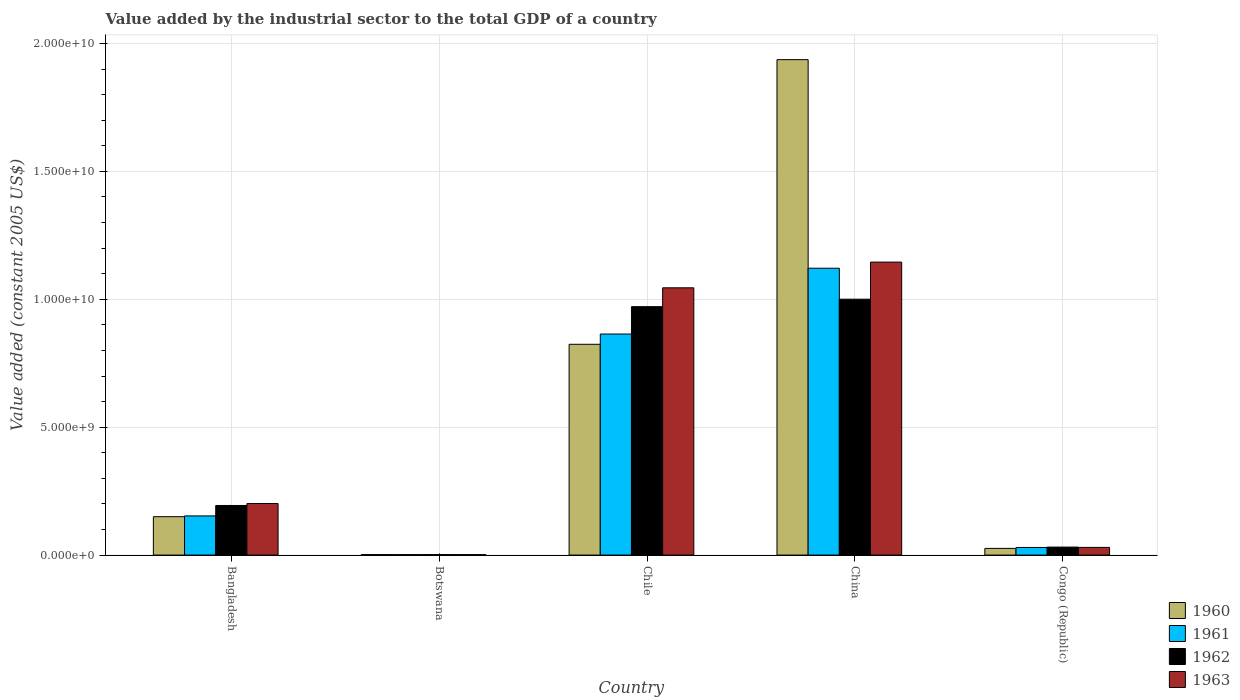How many different coloured bars are there?
Your response must be concise. 4. How many groups of bars are there?
Keep it short and to the point. 5. Are the number of bars per tick equal to the number of legend labels?
Give a very brief answer. Yes. Are the number of bars on each tick of the X-axis equal?
Offer a terse response. Yes. How many bars are there on the 1st tick from the left?
Make the answer very short. 4. How many bars are there on the 3rd tick from the right?
Your answer should be very brief. 4. What is the value added by the industrial sector in 1961 in Chile?
Offer a terse response. 8.64e+09. Across all countries, what is the maximum value added by the industrial sector in 1962?
Your answer should be compact. 1.00e+1. Across all countries, what is the minimum value added by the industrial sector in 1960?
Keep it short and to the point. 1.96e+07. In which country was the value added by the industrial sector in 1961 maximum?
Make the answer very short. China. In which country was the value added by the industrial sector in 1960 minimum?
Provide a short and direct response. Botswana. What is the total value added by the industrial sector in 1960 in the graph?
Your response must be concise. 2.94e+1. What is the difference between the value added by the industrial sector in 1960 in Bangladesh and that in Congo (Republic)?
Your answer should be very brief. 1.24e+09. What is the difference between the value added by the industrial sector in 1962 in Botswana and the value added by the industrial sector in 1961 in China?
Ensure brevity in your answer.  -1.12e+1. What is the average value added by the industrial sector in 1963 per country?
Give a very brief answer. 4.85e+09. What is the difference between the value added by the industrial sector of/in 1963 and value added by the industrial sector of/in 1962 in China?
Offer a very short reply. 1.45e+09. In how many countries, is the value added by the industrial sector in 1962 greater than 6000000000 US$?
Make the answer very short. 2. What is the ratio of the value added by the industrial sector in 1963 in Chile to that in China?
Provide a short and direct response. 0.91. Is the difference between the value added by the industrial sector in 1963 in Bangladesh and China greater than the difference between the value added by the industrial sector in 1962 in Bangladesh and China?
Your answer should be compact. No. What is the difference between the highest and the second highest value added by the industrial sector in 1960?
Ensure brevity in your answer.  1.79e+1. What is the difference between the highest and the lowest value added by the industrial sector in 1962?
Provide a succinct answer. 9.98e+09. In how many countries, is the value added by the industrial sector in 1963 greater than the average value added by the industrial sector in 1963 taken over all countries?
Provide a succinct answer. 2. Is the sum of the value added by the industrial sector in 1961 in Bangladesh and China greater than the maximum value added by the industrial sector in 1962 across all countries?
Offer a terse response. Yes. Is it the case that in every country, the sum of the value added by the industrial sector in 1960 and value added by the industrial sector in 1962 is greater than the sum of value added by the industrial sector in 1961 and value added by the industrial sector in 1963?
Keep it short and to the point. No. What does the 4th bar from the left in Chile represents?
Provide a succinct answer. 1963. Are all the bars in the graph horizontal?
Your response must be concise. No. How many countries are there in the graph?
Offer a terse response. 5. What is the difference between two consecutive major ticks on the Y-axis?
Your answer should be compact. 5.00e+09. Are the values on the major ticks of Y-axis written in scientific E-notation?
Offer a very short reply. Yes. Where does the legend appear in the graph?
Give a very brief answer. Bottom right. How are the legend labels stacked?
Give a very brief answer. Vertical. What is the title of the graph?
Your answer should be compact. Value added by the industrial sector to the total GDP of a country. Does "1994" appear as one of the legend labels in the graph?
Your answer should be compact. No. What is the label or title of the Y-axis?
Your response must be concise. Value added (constant 2005 US$). What is the Value added (constant 2005 US$) in 1960 in Bangladesh?
Give a very brief answer. 1.50e+09. What is the Value added (constant 2005 US$) of 1961 in Bangladesh?
Provide a short and direct response. 1.53e+09. What is the Value added (constant 2005 US$) of 1962 in Bangladesh?
Ensure brevity in your answer.  1.94e+09. What is the Value added (constant 2005 US$) in 1963 in Bangladesh?
Your answer should be compact. 2.01e+09. What is the Value added (constant 2005 US$) in 1960 in Botswana?
Your answer should be very brief. 1.96e+07. What is the Value added (constant 2005 US$) in 1961 in Botswana?
Your answer should be compact. 1.92e+07. What is the Value added (constant 2005 US$) in 1962 in Botswana?
Your answer should be compact. 1.98e+07. What is the Value added (constant 2005 US$) in 1963 in Botswana?
Your answer should be compact. 1.83e+07. What is the Value added (constant 2005 US$) of 1960 in Chile?
Make the answer very short. 8.24e+09. What is the Value added (constant 2005 US$) of 1961 in Chile?
Offer a very short reply. 8.64e+09. What is the Value added (constant 2005 US$) in 1962 in Chile?
Keep it short and to the point. 9.71e+09. What is the Value added (constant 2005 US$) of 1963 in Chile?
Provide a short and direct response. 1.04e+1. What is the Value added (constant 2005 US$) of 1960 in China?
Offer a very short reply. 1.94e+1. What is the Value added (constant 2005 US$) in 1961 in China?
Provide a short and direct response. 1.12e+1. What is the Value added (constant 2005 US$) in 1962 in China?
Give a very brief answer. 1.00e+1. What is the Value added (constant 2005 US$) in 1963 in China?
Your answer should be very brief. 1.15e+1. What is the Value added (constant 2005 US$) in 1960 in Congo (Republic)?
Offer a very short reply. 2.61e+08. What is the Value added (constant 2005 US$) in 1961 in Congo (Republic)?
Offer a very short reply. 2.98e+08. What is the Value added (constant 2005 US$) of 1962 in Congo (Republic)?
Provide a succinct answer. 3.12e+08. What is the Value added (constant 2005 US$) in 1963 in Congo (Republic)?
Keep it short and to the point. 3.00e+08. Across all countries, what is the maximum Value added (constant 2005 US$) in 1960?
Make the answer very short. 1.94e+1. Across all countries, what is the maximum Value added (constant 2005 US$) of 1961?
Provide a short and direct response. 1.12e+1. Across all countries, what is the maximum Value added (constant 2005 US$) of 1962?
Offer a very short reply. 1.00e+1. Across all countries, what is the maximum Value added (constant 2005 US$) of 1963?
Offer a very short reply. 1.15e+1. Across all countries, what is the minimum Value added (constant 2005 US$) of 1960?
Ensure brevity in your answer.  1.96e+07. Across all countries, what is the minimum Value added (constant 2005 US$) of 1961?
Keep it short and to the point. 1.92e+07. Across all countries, what is the minimum Value added (constant 2005 US$) in 1962?
Provide a short and direct response. 1.98e+07. Across all countries, what is the minimum Value added (constant 2005 US$) of 1963?
Make the answer very short. 1.83e+07. What is the total Value added (constant 2005 US$) of 1960 in the graph?
Make the answer very short. 2.94e+1. What is the total Value added (constant 2005 US$) of 1961 in the graph?
Offer a very short reply. 2.17e+1. What is the total Value added (constant 2005 US$) of 1962 in the graph?
Keep it short and to the point. 2.20e+1. What is the total Value added (constant 2005 US$) of 1963 in the graph?
Make the answer very short. 2.42e+1. What is the difference between the Value added (constant 2005 US$) of 1960 in Bangladesh and that in Botswana?
Ensure brevity in your answer.  1.48e+09. What is the difference between the Value added (constant 2005 US$) in 1961 in Bangladesh and that in Botswana?
Your answer should be very brief. 1.51e+09. What is the difference between the Value added (constant 2005 US$) in 1962 in Bangladesh and that in Botswana?
Give a very brief answer. 1.92e+09. What is the difference between the Value added (constant 2005 US$) in 1963 in Bangladesh and that in Botswana?
Give a very brief answer. 2.00e+09. What is the difference between the Value added (constant 2005 US$) of 1960 in Bangladesh and that in Chile?
Your answer should be very brief. -6.74e+09. What is the difference between the Value added (constant 2005 US$) of 1961 in Bangladesh and that in Chile?
Your response must be concise. -7.11e+09. What is the difference between the Value added (constant 2005 US$) of 1962 in Bangladesh and that in Chile?
Provide a succinct answer. -7.77e+09. What is the difference between the Value added (constant 2005 US$) of 1963 in Bangladesh and that in Chile?
Your answer should be very brief. -8.43e+09. What is the difference between the Value added (constant 2005 US$) in 1960 in Bangladesh and that in China?
Your answer should be compact. -1.79e+1. What is the difference between the Value added (constant 2005 US$) in 1961 in Bangladesh and that in China?
Your response must be concise. -9.68e+09. What is the difference between the Value added (constant 2005 US$) in 1962 in Bangladesh and that in China?
Your response must be concise. -8.06e+09. What is the difference between the Value added (constant 2005 US$) of 1963 in Bangladesh and that in China?
Your answer should be very brief. -9.44e+09. What is the difference between the Value added (constant 2005 US$) in 1960 in Bangladesh and that in Congo (Republic)?
Ensure brevity in your answer.  1.24e+09. What is the difference between the Value added (constant 2005 US$) in 1961 in Bangladesh and that in Congo (Republic)?
Give a very brief answer. 1.23e+09. What is the difference between the Value added (constant 2005 US$) of 1962 in Bangladesh and that in Congo (Republic)?
Ensure brevity in your answer.  1.63e+09. What is the difference between the Value added (constant 2005 US$) of 1963 in Bangladesh and that in Congo (Republic)?
Give a very brief answer. 1.71e+09. What is the difference between the Value added (constant 2005 US$) in 1960 in Botswana and that in Chile?
Make the answer very short. -8.22e+09. What is the difference between the Value added (constant 2005 US$) of 1961 in Botswana and that in Chile?
Make the answer very short. -8.62e+09. What is the difference between the Value added (constant 2005 US$) of 1962 in Botswana and that in Chile?
Provide a succinct answer. -9.69e+09. What is the difference between the Value added (constant 2005 US$) in 1963 in Botswana and that in Chile?
Make the answer very short. -1.04e+1. What is the difference between the Value added (constant 2005 US$) of 1960 in Botswana and that in China?
Give a very brief answer. -1.93e+1. What is the difference between the Value added (constant 2005 US$) of 1961 in Botswana and that in China?
Provide a succinct answer. -1.12e+1. What is the difference between the Value added (constant 2005 US$) of 1962 in Botswana and that in China?
Ensure brevity in your answer.  -9.98e+09. What is the difference between the Value added (constant 2005 US$) in 1963 in Botswana and that in China?
Give a very brief answer. -1.14e+1. What is the difference between the Value added (constant 2005 US$) of 1960 in Botswana and that in Congo (Republic)?
Offer a very short reply. -2.42e+08. What is the difference between the Value added (constant 2005 US$) of 1961 in Botswana and that in Congo (Republic)?
Ensure brevity in your answer.  -2.78e+08. What is the difference between the Value added (constant 2005 US$) of 1962 in Botswana and that in Congo (Republic)?
Provide a succinct answer. -2.93e+08. What is the difference between the Value added (constant 2005 US$) in 1963 in Botswana and that in Congo (Republic)?
Keep it short and to the point. -2.81e+08. What is the difference between the Value added (constant 2005 US$) in 1960 in Chile and that in China?
Give a very brief answer. -1.11e+1. What is the difference between the Value added (constant 2005 US$) in 1961 in Chile and that in China?
Offer a very short reply. -2.57e+09. What is the difference between the Value added (constant 2005 US$) in 1962 in Chile and that in China?
Your response must be concise. -2.92e+08. What is the difference between the Value added (constant 2005 US$) in 1963 in Chile and that in China?
Ensure brevity in your answer.  -1.01e+09. What is the difference between the Value added (constant 2005 US$) of 1960 in Chile and that in Congo (Republic)?
Your answer should be compact. 7.98e+09. What is the difference between the Value added (constant 2005 US$) in 1961 in Chile and that in Congo (Republic)?
Your response must be concise. 8.34e+09. What is the difference between the Value added (constant 2005 US$) in 1962 in Chile and that in Congo (Republic)?
Provide a short and direct response. 9.40e+09. What is the difference between the Value added (constant 2005 US$) of 1963 in Chile and that in Congo (Republic)?
Offer a very short reply. 1.01e+1. What is the difference between the Value added (constant 2005 US$) of 1960 in China and that in Congo (Republic)?
Offer a terse response. 1.91e+1. What is the difference between the Value added (constant 2005 US$) of 1961 in China and that in Congo (Republic)?
Your answer should be compact. 1.09e+1. What is the difference between the Value added (constant 2005 US$) of 1962 in China and that in Congo (Republic)?
Your answer should be compact. 9.69e+09. What is the difference between the Value added (constant 2005 US$) of 1963 in China and that in Congo (Republic)?
Your response must be concise. 1.12e+1. What is the difference between the Value added (constant 2005 US$) in 1960 in Bangladesh and the Value added (constant 2005 US$) in 1961 in Botswana?
Provide a short and direct response. 1.48e+09. What is the difference between the Value added (constant 2005 US$) in 1960 in Bangladesh and the Value added (constant 2005 US$) in 1962 in Botswana?
Make the answer very short. 1.48e+09. What is the difference between the Value added (constant 2005 US$) of 1960 in Bangladesh and the Value added (constant 2005 US$) of 1963 in Botswana?
Your answer should be compact. 1.48e+09. What is the difference between the Value added (constant 2005 US$) in 1961 in Bangladesh and the Value added (constant 2005 US$) in 1962 in Botswana?
Give a very brief answer. 1.51e+09. What is the difference between the Value added (constant 2005 US$) of 1961 in Bangladesh and the Value added (constant 2005 US$) of 1963 in Botswana?
Ensure brevity in your answer.  1.51e+09. What is the difference between the Value added (constant 2005 US$) in 1962 in Bangladesh and the Value added (constant 2005 US$) in 1963 in Botswana?
Your response must be concise. 1.92e+09. What is the difference between the Value added (constant 2005 US$) of 1960 in Bangladesh and the Value added (constant 2005 US$) of 1961 in Chile?
Offer a terse response. -7.14e+09. What is the difference between the Value added (constant 2005 US$) of 1960 in Bangladesh and the Value added (constant 2005 US$) of 1962 in Chile?
Provide a short and direct response. -8.21e+09. What is the difference between the Value added (constant 2005 US$) in 1960 in Bangladesh and the Value added (constant 2005 US$) in 1963 in Chile?
Provide a succinct answer. -8.95e+09. What is the difference between the Value added (constant 2005 US$) in 1961 in Bangladesh and the Value added (constant 2005 US$) in 1962 in Chile?
Offer a very short reply. -8.18e+09. What is the difference between the Value added (constant 2005 US$) in 1961 in Bangladesh and the Value added (constant 2005 US$) in 1963 in Chile?
Make the answer very short. -8.92e+09. What is the difference between the Value added (constant 2005 US$) of 1962 in Bangladesh and the Value added (constant 2005 US$) of 1963 in Chile?
Offer a terse response. -8.51e+09. What is the difference between the Value added (constant 2005 US$) of 1960 in Bangladesh and the Value added (constant 2005 US$) of 1961 in China?
Provide a short and direct response. -9.71e+09. What is the difference between the Value added (constant 2005 US$) of 1960 in Bangladesh and the Value added (constant 2005 US$) of 1962 in China?
Make the answer very short. -8.50e+09. What is the difference between the Value added (constant 2005 US$) in 1960 in Bangladesh and the Value added (constant 2005 US$) in 1963 in China?
Your answer should be very brief. -9.95e+09. What is the difference between the Value added (constant 2005 US$) in 1961 in Bangladesh and the Value added (constant 2005 US$) in 1962 in China?
Provide a succinct answer. -8.47e+09. What is the difference between the Value added (constant 2005 US$) in 1961 in Bangladesh and the Value added (constant 2005 US$) in 1963 in China?
Your answer should be very brief. -9.92e+09. What is the difference between the Value added (constant 2005 US$) in 1962 in Bangladesh and the Value added (constant 2005 US$) in 1963 in China?
Make the answer very short. -9.51e+09. What is the difference between the Value added (constant 2005 US$) of 1960 in Bangladesh and the Value added (constant 2005 US$) of 1961 in Congo (Republic)?
Ensure brevity in your answer.  1.20e+09. What is the difference between the Value added (constant 2005 US$) of 1960 in Bangladesh and the Value added (constant 2005 US$) of 1962 in Congo (Republic)?
Give a very brief answer. 1.19e+09. What is the difference between the Value added (constant 2005 US$) in 1960 in Bangladesh and the Value added (constant 2005 US$) in 1963 in Congo (Republic)?
Offer a terse response. 1.20e+09. What is the difference between the Value added (constant 2005 US$) of 1961 in Bangladesh and the Value added (constant 2005 US$) of 1962 in Congo (Republic)?
Offer a terse response. 1.22e+09. What is the difference between the Value added (constant 2005 US$) in 1961 in Bangladesh and the Value added (constant 2005 US$) in 1963 in Congo (Republic)?
Give a very brief answer. 1.23e+09. What is the difference between the Value added (constant 2005 US$) of 1962 in Bangladesh and the Value added (constant 2005 US$) of 1963 in Congo (Republic)?
Give a very brief answer. 1.64e+09. What is the difference between the Value added (constant 2005 US$) of 1960 in Botswana and the Value added (constant 2005 US$) of 1961 in Chile?
Provide a short and direct response. -8.62e+09. What is the difference between the Value added (constant 2005 US$) in 1960 in Botswana and the Value added (constant 2005 US$) in 1962 in Chile?
Provide a short and direct response. -9.69e+09. What is the difference between the Value added (constant 2005 US$) of 1960 in Botswana and the Value added (constant 2005 US$) of 1963 in Chile?
Offer a terse response. -1.04e+1. What is the difference between the Value added (constant 2005 US$) of 1961 in Botswana and the Value added (constant 2005 US$) of 1962 in Chile?
Give a very brief answer. -9.69e+09. What is the difference between the Value added (constant 2005 US$) of 1961 in Botswana and the Value added (constant 2005 US$) of 1963 in Chile?
Offer a terse response. -1.04e+1. What is the difference between the Value added (constant 2005 US$) in 1962 in Botswana and the Value added (constant 2005 US$) in 1963 in Chile?
Give a very brief answer. -1.04e+1. What is the difference between the Value added (constant 2005 US$) of 1960 in Botswana and the Value added (constant 2005 US$) of 1961 in China?
Offer a terse response. -1.12e+1. What is the difference between the Value added (constant 2005 US$) of 1960 in Botswana and the Value added (constant 2005 US$) of 1962 in China?
Your response must be concise. -9.98e+09. What is the difference between the Value added (constant 2005 US$) of 1960 in Botswana and the Value added (constant 2005 US$) of 1963 in China?
Your answer should be compact. -1.14e+1. What is the difference between the Value added (constant 2005 US$) in 1961 in Botswana and the Value added (constant 2005 US$) in 1962 in China?
Offer a very short reply. -9.98e+09. What is the difference between the Value added (constant 2005 US$) in 1961 in Botswana and the Value added (constant 2005 US$) in 1963 in China?
Your response must be concise. -1.14e+1. What is the difference between the Value added (constant 2005 US$) in 1962 in Botswana and the Value added (constant 2005 US$) in 1963 in China?
Offer a very short reply. -1.14e+1. What is the difference between the Value added (constant 2005 US$) of 1960 in Botswana and the Value added (constant 2005 US$) of 1961 in Congo (Republic)?
Give a very brief answer. -2.78e+08. What is the difference between the Value added (constant 2005 US$) of 1960 in Botswana and the Value added (constant 2005 US$) of 1962 in Congo (Republic)?
Your answer should be compact. -2.93e+08. What is the difference between the Value added (constant 2005 US$) in 1960 in Botswana and the Value added (constant 2005 US$) in 1963 in Congo (Republic)?
Ensure brevity in your answer.  -2.80e+08. What is the difference between the Value added (constant 2005 US$) of 1961 in Botswana and the Value added (constant 2005 US$) of 1962 in Congo (Republic)?
Provide a short and direct response. -2.93e+08. What is the difference between the Value added (constant 2005 US$) of 1961 in Botswana and the Value added (constant 2005 US$) of 1963 in Congo (Republic)?
Your response must be concise. -2.81e+08. What is the difference between the Value added (constant 2005 US$) in 1962 in Botswana and the Value added (constant 2005 US$) in 1963 in Congo (Republic)?
Offer a very short reply. -2.80e+08. What is the difference between the Value added (constant 2005 US$) of 1960 in Chile and the Value added (constant 2005 US$) of 1961 in China?
Your response must be concise. -2.97e+09. What is the difference between the Value added (constant 2005 US$) of 1960 in Chile and the Value added (constant 2005 US$) of 1962 in China?
Your answer should be compact. -1.76e+09. What is the difference between the Value added (constant 2005 US$) in 1960 in Chile and the Value added (constant 2005 US$) in 1963 in China?
Your answer should be compact. -3.21e+09. What is the difference between the Value added (constant 2005 US$) in 1961 in Chile and the Value added (constant 2005 US$) in 1962 in China?
Make the answer very short. -1.36e+09. What is the difference between the Value added (constant 2005 US$) of 1961 in Chile and the Value added (constant 2005 US$) of 1963 in China?
Provide a succinct answer. -2.81e+09. What is the difference between the Value added (constant 2005 US$) of 1962 in Chile and the Value added (constant 2005 US$) of 1963 in China?
Your answer should be compact. -1.74e+09. What is the difference between the Value added (constant 2005 US$) of 1960 in Chile and the Value added (constant 2005 US$) of 1961 in Congo (Republic)?
Your response must be concise. 7.94e+09. What is the difference between the Value added (constant 2005 US$) of 1960 in Chile and the Value added (constant 2005 US$) of 1962 in Congo (Republic)?
Offer a very short reply. 7.93e+09. What is the difference between the Value added (constant 2005 US$) of 1960 in Chile and the Value added (constant 2005 US$) of 1963 in Congo (Republic)?
Your answer should be very brief. 7.94e+09. What is the difference between the Value added (constant 2005 US$) of 1961 in Chile and the Value added (constant 2005 US$) of 1962 in Congo (Republic)?
Offer a terse response. 8.33e+09. What is the difference between the Value added (constant 2005 US$) of 1961 in Chile and the Value added (constant 2005 US$) of 1963 in Congo (Republic)?
Your answer should be very brief. 8.34e+09. What is the difference between the Value added (constant 2005 US$) in 1962 in Chile and the Value added (constant 2005 US$) in 1963 in Congo (Republic)?
Ensure brevity in your answer.  9.41e+09. What is the difference between the Value added (constant 2005 US$) in 1960 in China and the Value added (constant 2005 US$) in 1961 in Congo (Republic)?
Your response must be concise. 1.91e+1. What is the difference between the Value added (constant 2005 US$) in 1960 in China and the Value added (constant 2005 US$) in 1962 in Congo (Republic)?
Provide a succinct answer. 1.91e+1. What is the difference between the Value added (constant 2005 US$) in 1960 in China and the Value added (constant 2005 US$) in 1963 in Congo (Republic)?
Provide a short and direct response. 1.91e+1. What is the difference between the Value added (constant 2005 US$) in 1961 in China and the Value added (constant 2005 US$) in 1962 in Congo (Republic)?
Your response must be concise. 1.09e+1. What is the difference between the Value added (constant 2005 US$) of 1961 in China and the Value added (constant 2005 US$) of 1963 in Congo (Republic)?
Give a very brief answer. 1.09e+1. What is the difference between the Value added (constant 2005 US$) in 1962 in China and the Value added (constant 2005 US$) in 1963 in Congo (Republic)?
Offer a terse response. 9.70e+09. What is the average Value added (constant 2005 US$) in 1960 per country?
Your answer should be very brief. 5.88e+09. What is the average Value added (constant 2005 US$) of 1961 per country?
Offer a very short reply. 4.34e+09. What is the average Value added (constant 2005 US$) of 1962 per country?
Offer a terse response. 4.40e+09. What is the average Value added (constant 2005 US$) in 1963 per country?
Your answer should be very brief. 4.85e+09. What is the difference between the Value added (constant 2005 US$) in 1960 and Value added (constant 2005 US$) in 1961 in Bangladesh?
Your response must be concise. -3.05e+07. What is the difference between the Value added (constant 2005 US$) of 1960 and Value added (constant 2005 US$) of 1962 in Bangladesh?
Ensure brevity in your answer.  -4.38e+08. What is the difference between the Value added (constant 2005 US$) in 1960 and Value added (constant 2005 US$) in 1963 in Bangladesh?
Make the answer very short. -5.14e+08. What is the difference between the Value added (constant 2005 US$) of 1961 and Value added (constant 2005 US$) of 1962 in Bangladesh?
Offer a terse response. -4.08e+08. What is the difference between the Value added (constant 2005 US$) of 1961 and Value added (constant 2005 US$) of 1963 in Bangladesh?
Provide a succinct answer. -4.84e+08. What is the difference between the Value added (constant 2005 US$) in 1962 and Value added (constant 2005 US$) in 1963 in Bangladesh?
Provide a succinct answer. -7.60e+07. What is the difference between the Value added (constant 2005 US$) of 1960 and Value added (constant 2005 US$) of 1961 in Botswana?
Offer a very short reply. 4.24e+05. What is the difference between the Value added (constant 2005 US$) in 1960 and Value added (constant 2005 US$) in 1962 in Botswana?
Keep it short and to the point. -2.12e+05. What is the difference between the Value added (constant 2005 US$) in 1960 and Value added (constant 2005 US$) in 1963 in Botswana?
Your answer should be compact. 1.27e+06. What is the difference between the Value added (constant 2005 US$) of 1961 and Value added (constant 2005 US$) of 1962 in Botswana?
Offer a very short reply. -6.36e+05. What is the difference between the Value added (constant 2005 US$) of 1961 and Value added (constant 2005 US$) of 1963 in Botswana?
Give a very brief answer. 8.48e+05. What is the difference between the Value added (constant 2005 US$) of 1962 and Value added (constant 2005 US$) of 1963 in Botswana?
Offer a very short reply. 1.48e+06. What is the difference between the Value added (constant 2005 US$) in 1960 and Value added (constant 2005 US$) in 1961 in Chile?
Your answer should be compact. -4.01e+08. What is the difference between the Value added (constant 2005 US$) of 1960 and Value added (constant 2005 US$) of 1962 in Chile?
Your answer should be very brief. -1.47e+09. What is the difference between the Value added (constant 2005 US$) in 1960 and Value added (constant 2005 US$) in 1963 in Chile?
Offer a very short reply. -2.21e+09. What is the difference between the Value added (constant 2005 US$) in 1961 and Value added (constant 2005 US$) in 1962 in Chile?
Provide a short and direct response. -1.07e+09. What is the difference between the Value added (constant 2005 US$) in 1961 and Value added (constant 2005 US$) in 1963 in Chile?
Ensure brevity in your answer.  -1.81e+09. What is the difference between the Value added (constant 2005 US$) of 1962 and Value added (constant 2005 US$) of 1963 in Chile?
Provide a succinct answer. -7.37e+08. What is the difference between the Value added (constant 2005 US$) of 1960 and Value added (constant 2005 US$) of 1961 in China?
Give a very brief answer. 8.15e+09. What is the difference between the Value added (constant 2005 US$) of 1960 and Value added (constant 2005 US$) of 1962 in China?
Provide a succinct answer. 9.36e+09. What is the difference between the Value added (constant 2005 US$) of 1960 and Value added (constant 2005 US$) of 1963 in China?
Offer a very short reply. 7.91e+09. What is the difference between the Value added (constant 2005 US$) in 1961 and Value added (constant 2005 US$) in 1962 in China?
Your response must be concise. 1.21e+09. What is the difference between the Value added (constant 2005 US$) in 1961 and Value added (constant 2005 US$) in 1963 in China?
Offer a terse response. -2.39e+08. What is the difference between the Value added (constant 2005 US$) of 1962 and Value added (constant 2005 US$) of 1963 in China?
Offer a terse response. -1.45e+09. What is the difference between the Value added (constant 2005 US$) in 1960 and Value added (constant 2005 US$) in 1961 in Congo (Republic)?
Ensure brevity in your answer.  -3.63e+07. What is the difference between the Value added (constant 2005 US$) in 1960 and Value added (constant 2005 US$) in 1962 in Congo (Republic)?
Your response must be concise. -5.10e+07. What is the difference between the Value added (constant 2005 US$) in 1960 and Value added (constant 2005 US$) in 1963 in Congo (Republic)?
Ensure brevity in your answer.  -3.84e+07. What is the difference between the Value added (constant 2005 US$) in 1961 and Value added (constant 2005 US$) in 1962 in Congo (Republic)?
Your response must be concise. -1.47e+07. What is the difference between the Value added (constant 2005 US$) of 1961 and Value added (constant 2005 US$) of 1963 in Congo (Republic)?
Your answer should be very brief. -2.10e+06. What is the difference between the Value added (constant 2005 US$) in 1962 and Value added (constant 2005 US$) in 1963 in Congo (Republic)?
Make the answer very short. 1.26e+07. What is the ratio of the Value added (constant 2005 US$) in 1960 in Bangladesh to that in Botswana?
Keep it short and to the point. 76.48. What is the ratio of the Value added (constant 2005 US$) of 1961 in Bangladesh to that in Botswana?
Provide a succinct answer. 79.76. What is the ratio of the Value added (constant 2005 US$) in 1962 in Bangladesh to that in Botswana?
Offer a terse response. 97.78. What is the ratio of the Value added (constant 2005 US$) of 1963 in Bangladesh to that in Botswana?
Give a very brief answer. 109.83. What is the ratio of the Value added (constant 2005 US$) of 1960 in Bangladesh to that in Chile?
Make the answer very short. 0.18. What is the ratio of the Value added (constant 2005 US$) of 1961 in Bangladesh to that in Chile?
Your response must be concise. 0.18. What is the ratio of the Value added (constant 2005 US$) in 1962 in Bangladesh to that in Chile?
Offer a terse response. 0.2. What is the ratio of the Value added (constant 2005 US$) of 1963 in Bangladesh to that in Chile?
Ensure brevity in your answer.  0.19. What is the ratio of the Value added (constant 2005 US$) in 1960 in Bangladesh to that in China?
Provide a short and direct response. 0.08. What is the ratio of the Value added (constant 2005 US$) of 1961 in Bangladesh to that in China?
Keep it short and to the point. 0.14. What is the ratio of the Value added (constant 2005 US$) in 1962 in Bangladesh to that in China?
Keep it short and to the point. 0.19. What is the ratio of the Value added (constant 2005 US$) of 1963 in Bangladesh to that in China?
Give a very brief answer. 0.18. What is the ratio of the Value added (constant 2005 US$) of 1960 in Bangladesh to that in Congo (Republic)?
Make the answer very short. 5.74. What is the ratio of the Value added (constant 2005 US$) of 1961 in Bangladesh to that in Congo (Republic)?
Your answer should be compact. 5.14. What is the ratio of the Value added (constant 2005 US$) of 1962 in Bangladesh to that in Congo (Republic)?
Your answer should be compact. 6.21. What is the ratio of the Value added (constant 2005 US$) in 1963 in Bangladesh to that in Congo (Republic)?
Your answer should be very brief. 6.72. What is the ratio of the Value added (constant 2005 US$) in 1960 in Botswana to that in Chile?
Ensure brevity in your answer.  0. What is the ratio of the Value added (constant 2005 US$) in 1961 in Botswana to that in Chile?
Offer a very short reply. 0. What is the ratio of the Value added (constant 2005 US$) of 1962 in Botswana to that in Chile?
Make the answer very short. 0. What is the ratio of the Value added (constant 2005 US$) in 1963 in Botswana to that in Chile?
Make the answer very short. 0. What is the ratio of the Value added (constant 2005 US$) of 1961 in Botswana to that in China?
Make the answer very short. 0. What is the ratio of the Value added (constant 2005 US$) of 1962 in Botswana to that in China?
Provide a short and direct response. 0. What is the ratio of the Value added (constant 2005 US$) in 1963 in Botswana to that in China?
Offer a very short reply. 0. What is the ratio of the Value added (constant 2005 US$) of 1960 in Botswana to that in Congo (Republic)?
Give a very brief answer. 0.07. What is the ratio of the Value added (constant 2005 US$) in 1961 in Botswana to that in Congo (Republic)?
Provide a succinct answer. 0.06. What is the ratio of the Value added (constant 2005 US$) of 1962 in Botswana to that in Congo (Republic)?
Make the answer very short. 0.06. What is the ratio of the Value added (constant 2005 US$) of 1963 in Botswana to that in Congo (Republic)?
Make the answer very short. 0.06. What is the ratio of the Value added (constant 2005 US$) of 1960 in Chile to that in China?
Your answer should be compact. 0.43. What is the ratio of the Value added (constant 2005 US$) of 1961 in Chile to that in China?
Make the answer very short. 0.77. What is the ratio of the Value added (constant 2005 US$) of 1962 in Chile to that in China?
Provide a short and direct response. 0.97. What is the ratio of the Value added (constant 2005 US$) of 1963 in Chile to that in China?
Offer a very short reply. 0.91. What is the ratio of the Value added (constant 2005 US$) in 1960 in Chile to that in Congo (Republic)?
Make the answer very short. 31.52. What is the ratio of the Value added (constant 2005 US$) of 1961 in Chile to that in Congo (Republic)?
Provide a succinct answer. 29.03. What is the ratio of the Value added (constant 2005 US$) in 1962 in Chile to that in Congo (Republic)?
Give a very brief answer. 31.09. What is the ratio of the Value added (constant 2005 US$) of 1963 in Chile to that in Congo (Republic)?
Offer a very short reply. 34.85. What is the ratio of the Value added (constant 2005 US$) in 1960 in China to that in Congo (Republic)?
Give a very brief answer. 74.09. What is the ratio of the Value added (constant 2005 US$) of 1961 in China to that in Congo (Republic)?
Your response must be concise. 37.67. What is the ratio of the Value added (constant 2005 US$) in 1962 in China to that in Congo (Republic)?
Give a very brief answer. 32.02. What is the ratio of the Value added (constant 2005 US$) in 1963 in China to that in Congo (Republic)?
Ensure brevity in your answer.  38.21. What is the difference between the highest and the second highest Value added (constant 2005 US$) of 1960?
Provide a succinct answer. 1.11e+1. What is the difference between the highest and the second highest Value added (constant 2005 US$) in 1961?
Offer a very short reply. 2.57e+09. What is the difference between the highest and the second highest Value added (constant 2005 US$) of 1962?
Give a very brief answer. 2.92e+08. What is the difference between the highest and the second highest Value added (constant 2005 US$) of 1963?
Give a very brief answer. 1.01e+09. What is the difference between the highest and the lowest Value added (constant 2005 US$) of 1960?
Provide a succinct answer. 1.93e+1. What is the difference between the highest and the lowest Value added (constant 2005 US$) of 1961?
Your answer should be compact. 1.12e+1. What is the difference between the highest and the lowest Value added (constant 2005 US$) of 1962?
Offer a very short reply. 9.98e+09. What is the difference between the highest and the lowest Value added (constant 2005 US$) of 1963?
Your answer should be compact. 1.14e+1. 